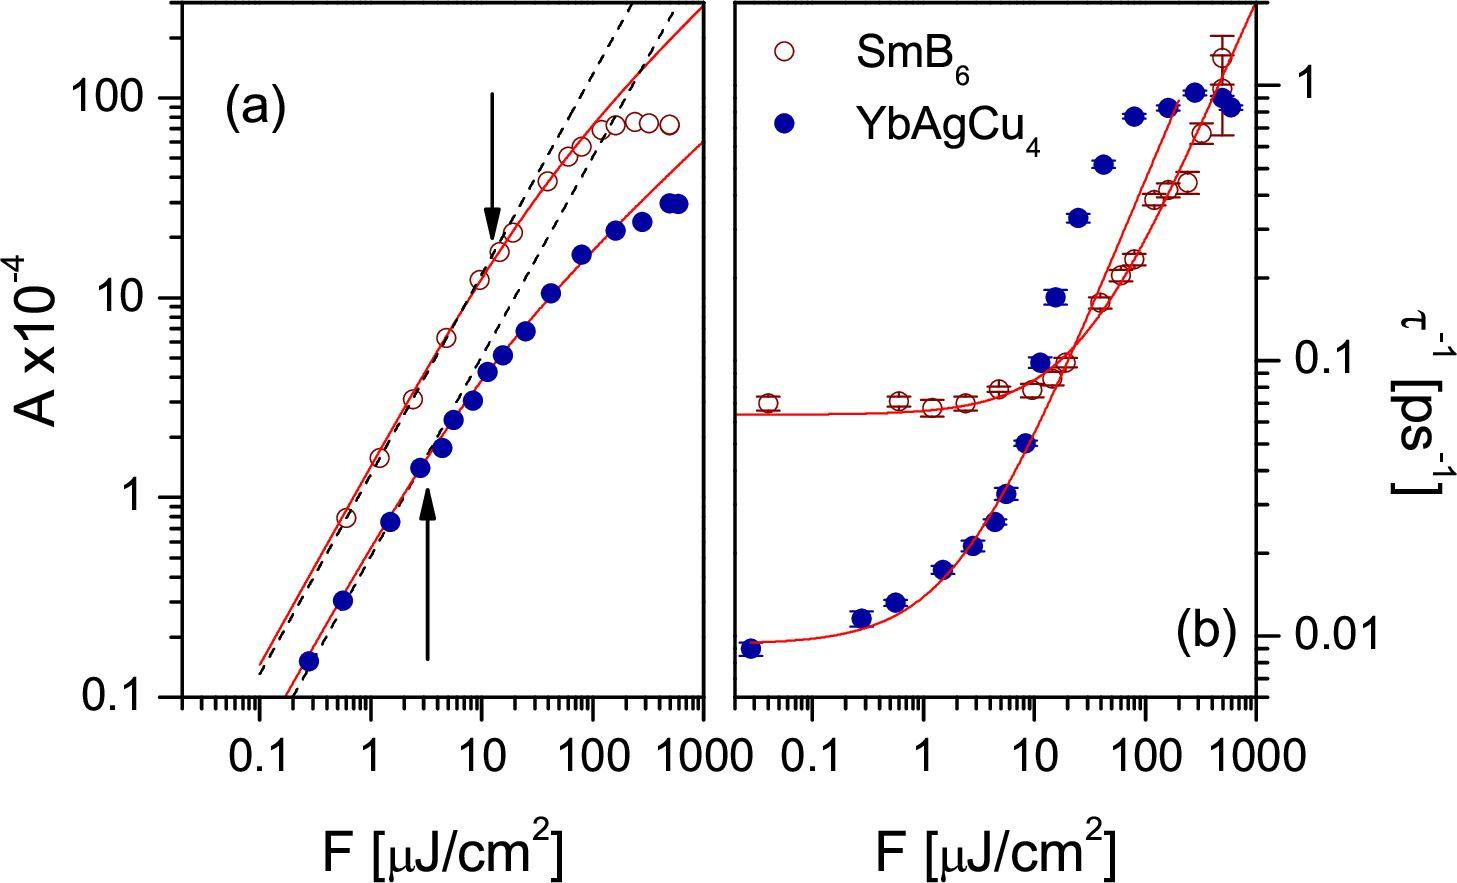What does the arrow in figure (a) most likely indicate about the relationship between 'A' and 'F'? A direct linear relationship throughout A threshold point after which the relationship changes No significant relationship between 'A' and 'F' An exponential decrease of 'A' with increasing 'F' The arrow in figure (a) points to a location on the curve that appears to indicate a change in the slope of the line, suggesting a threshold point beyond which the relationship between 'A' and 'F' changes. Therefore, the correct answer is B. 